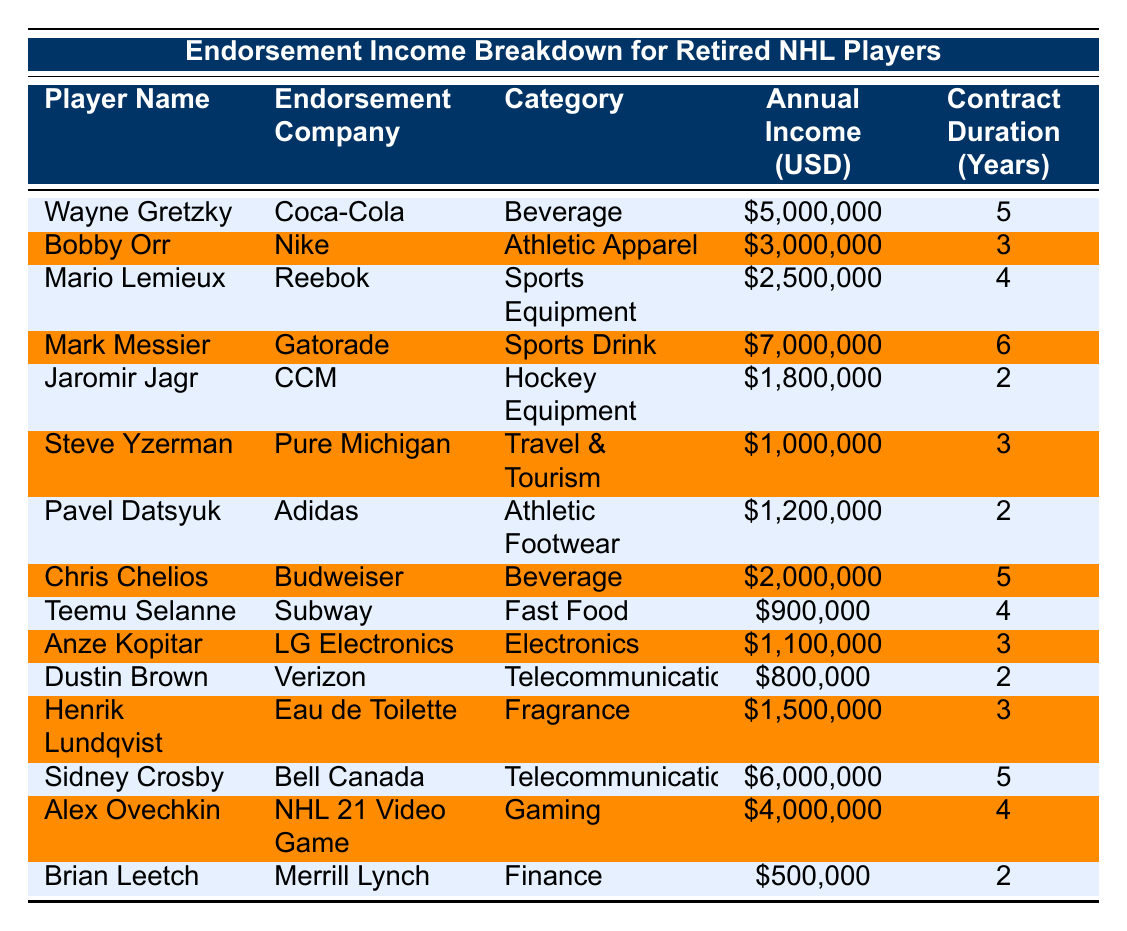What is the annual income of Wayne Gretzky from endorsements? The table lists Wayne Gretzky's annual income as $5,000,000 under the "Annual Income (USD)" column.
Answer: $5,000,000 Which player has the highest annual endorsement income? By comparing the annual incomes in the table, Mark Messier has the highest annual income at $7,000,000.
Answer: Mark Messier How many years is Bobby Orr's endorsement contract? In the table, under the "Contract Duration (Years)" column for Bobby Orr, it shows that his contract lasts for 3 years.
Answer: 3 years What is the total endorsement income of all players combined? Adding up all the annual incomes: $5,000,000 + $3,000,000 + $2,500,000 + $7,000,000 + $1,800,000 + $1,000,000 + $1,200,000 + $2,000,000 + $900,000 + $1,100,000 + $800,000 + $1,500,000 + $6,000,000 + $4,000,000 + $500,000 = $37,600,000.
Answer: $37,600,000 Which company has the lowest endorsement contract value? Look at the "Annual Income (USD)" column, it's clear that Dustin Brown has the lowest annual income at $800,000, making Verizon the company with the lowest endorsement value in the table.
Answer: Verizon Is Chris Chelios associated with a beverage company? Yes, the table shows Chris Chelios's endorsement with Budweiser, which is a beverage company.
Answer: Yes What is the average annual income of retired NHL players in this table? To find the average, first sum all annual incomes ($37,600,000) and then divide by the number of players (14). So, the average annual income is $37,600,000 / 14 = $2,685,714.29.
Answer: $2,685,714.29 How many players endorsed companies in the telecommunications sector? The table shows two players: Sidney Crosby with Bell Canada and Dustin Brown with Verizon under the "Category" column for Telecommunications, so there are 2 players.
Answer: 2 players Who earned more from endorsements, Mario Lemieux or Pavel Datsyuk? Comparing their incomes, Mario Lemieux has $2,500,000 and Pavel Datsyuk has $1,200,000. Since $2,500,000 is greater than $1,200,000, Mario Lemieux earned more.
Answer: Mario Lemieux What is the total income from beverage endorsements in the table? There are two players with beverage endorsements: Wayne Gretzky with $5,000,000 and Chris Chelios with $2,000,000. Adding these gives $5,000,000 + $2,000,000 = $7,000,000.
Answer: $7,000,000 Which retired NHL player has an endorsement in the fast food category? The table shows Teemu Selanne associated with Subway, which is categorized under Fast Food.
Answer: Teemu Selanne 